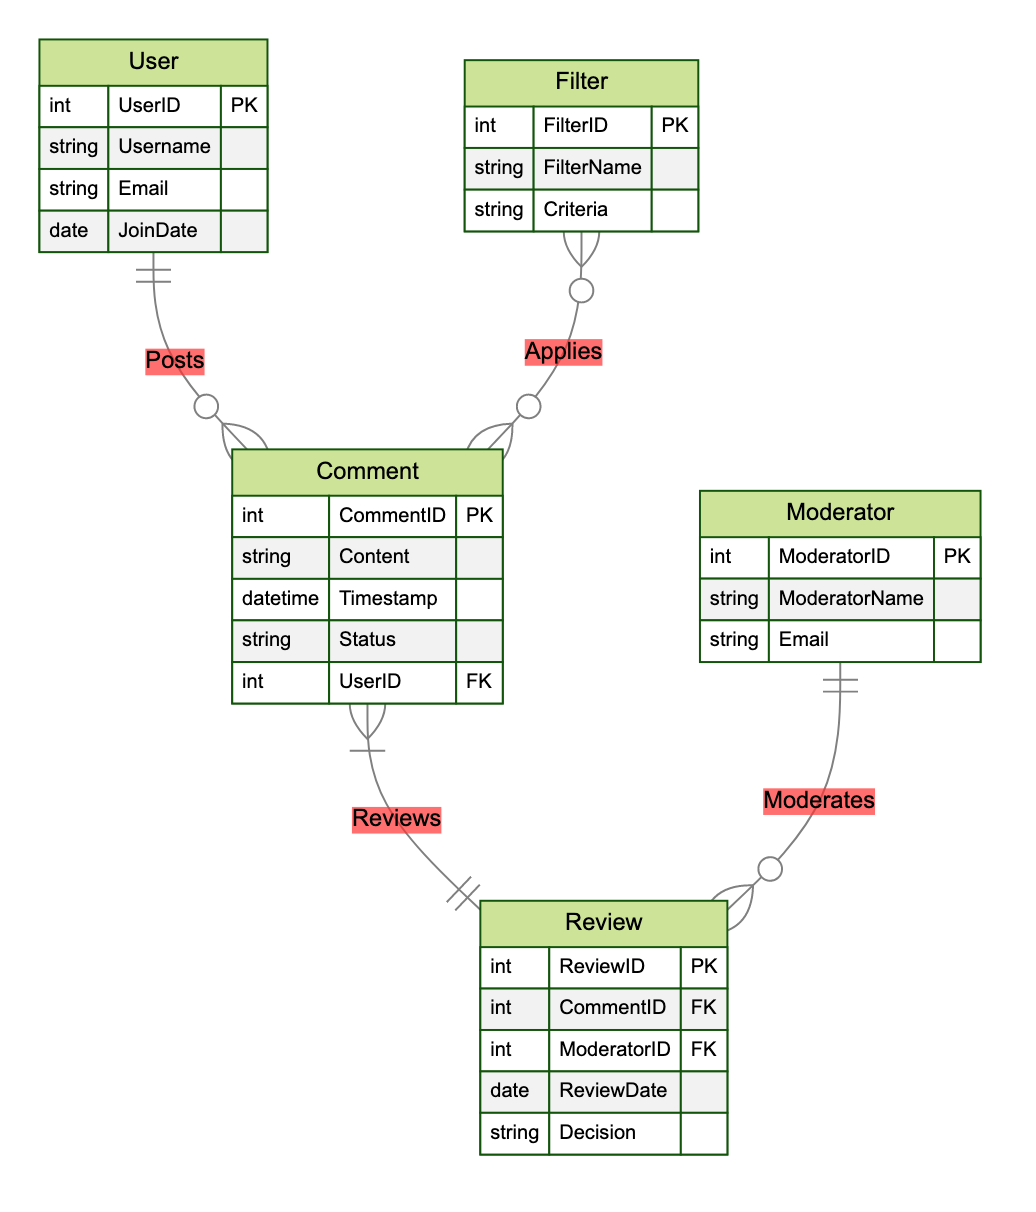what is the primary key of the User entity? The primary key for the User entity is UserID, which uniquely identifies each user in the database. This is indicated by the notation "PK" next to UserID in the entity description.
Answer: UserID how many entities are present in the diagram? There are five distinct entities shown in the diagram: User, Comment, Moderator, Filter, and Review. Each distinct group represents a different part of the content moderation process.
Answer: 5 which entity is linked directly to both Comment and Review entities? The Comment entity is directly linked to both the Review entity (through the Reviews relationship) and is also posted by the User entity. This indicates its central role in the moderation process.
Answer: Comment how many relationships are there in total? The diagram depicts four distinct relationships: Posts, Moderates, Reviews, and Applies. Each relationship connects different entities to establish how they interact in the moderation process.
Answer: 4 which entity contains the attribute 'Decision'? The Decision attribute is found within the Review entity, which records the outcomes of moderation actions taken by moderators on specific comments.
Answer: Review who moderates the comments based on the Review entity? The entity that moderates comments is the Moderator. They are linked to the Review entity through the Moderates relationship, indicating their role in reviewing comments.
Answer: Moderator which entity can apply a filter to a comment? The entity that can apply a filter to a comment is the Filter entity, which is connected via the Applies relationship. This indicates that comments may be subjected to various filters based on specified criteria.
Answer: Filter what is the foreign key in the Comment entity? The foreign key in the Comment entity is UserID, which links each comment to its respective user by referencing their unique ID from the User entity.
Answer: UserID what is the primary key of the Review entity? The primary key for the Review entity is ReviewID, which is designated to uniquely identify each review made by a moderator regarding a comment.
Answer: ReviewID 